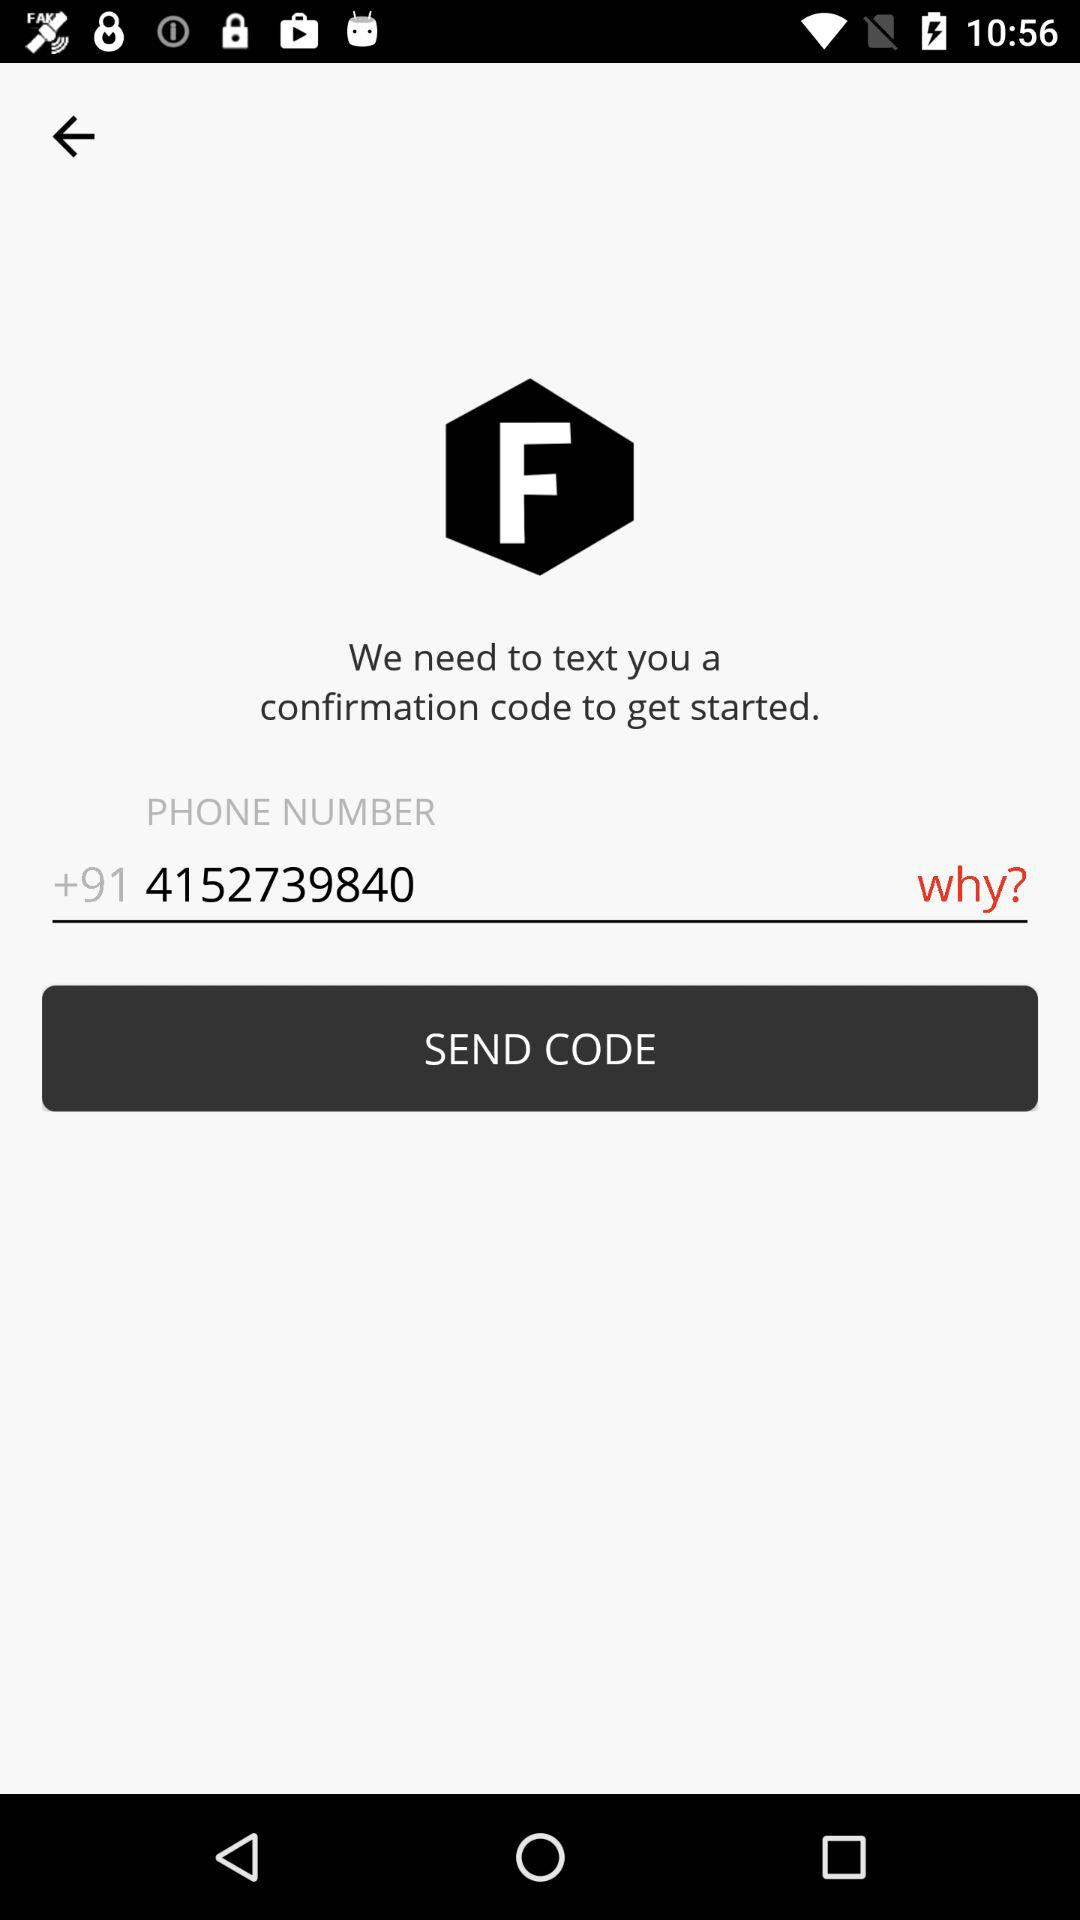What is the given country code? The given country code is +91. 